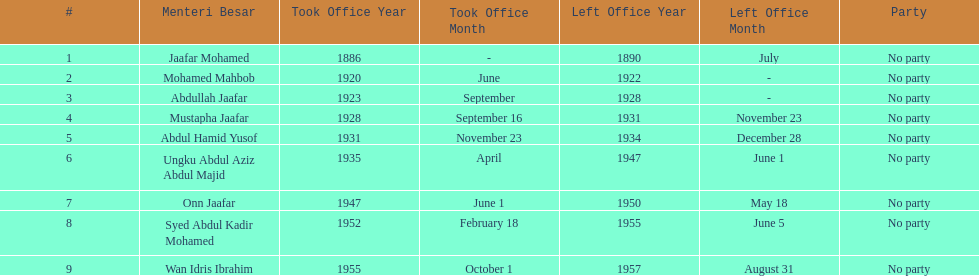Name someone who was not in office more than 4 years. Mohamed Mahbob. 